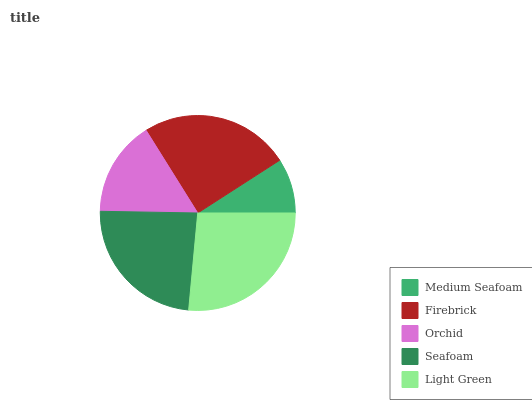Is Medium Seafoam the minimum?
Answer yes or no. Yes. Is Light Green the maximum?
Answer yes or no. Yes. Is Firebrick the minimum?
Answer yes or no. No. Is Firebrick the maximum?
Answer yes or no. No. Is Firebrick greater than Medium Seafoam?
Answer yes or no. Yes. Is Medium Seafoam less than Firebrick?
Answer yes or no. Yes. Is Medium Seafoam greater than Firebrick?
Answer yes or no. No. Is Firebrick less than Medium Seafoam?
Answer yes or no. No. Is Seafoam the high median?
Answer yes or no. Yes. Is Seafoam the low median?
Answer yes or no. Yes. Is Orchid the high median?
Answer yes or no. No. Is Orchid the low median?
Answer yes or no. No. 